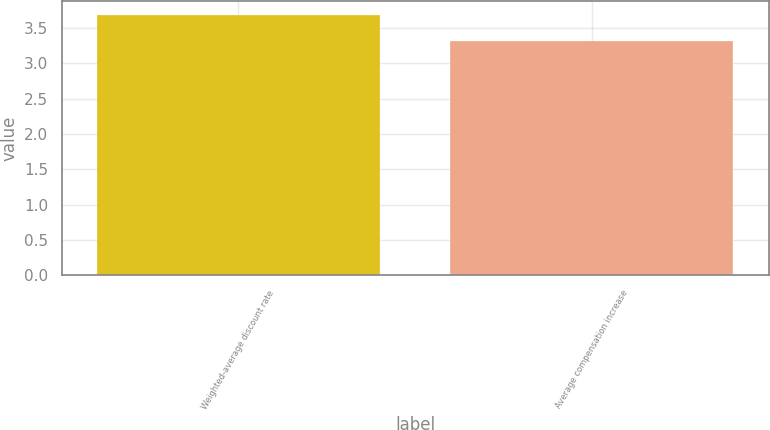<chart> <loc_0><loc_0><loc_500><loc_500><bar_chart><fcel>Weighted-average discount rate<fcel>Average compensation increase<nl><fcel>3.69<fcel>3.31<nl></chart> 